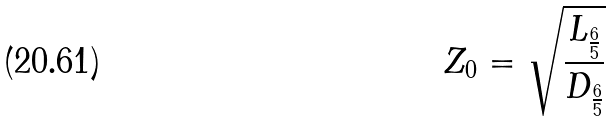Convert formula to latex. <formula><loc_0><loc_0><loc_500><loc_500>Z _ { 0 } = \sqrt { \frac { L _ { \frac { 6 } { 5 } } } { D _ { \frac { 6 } { 5 } } } }</formula> 